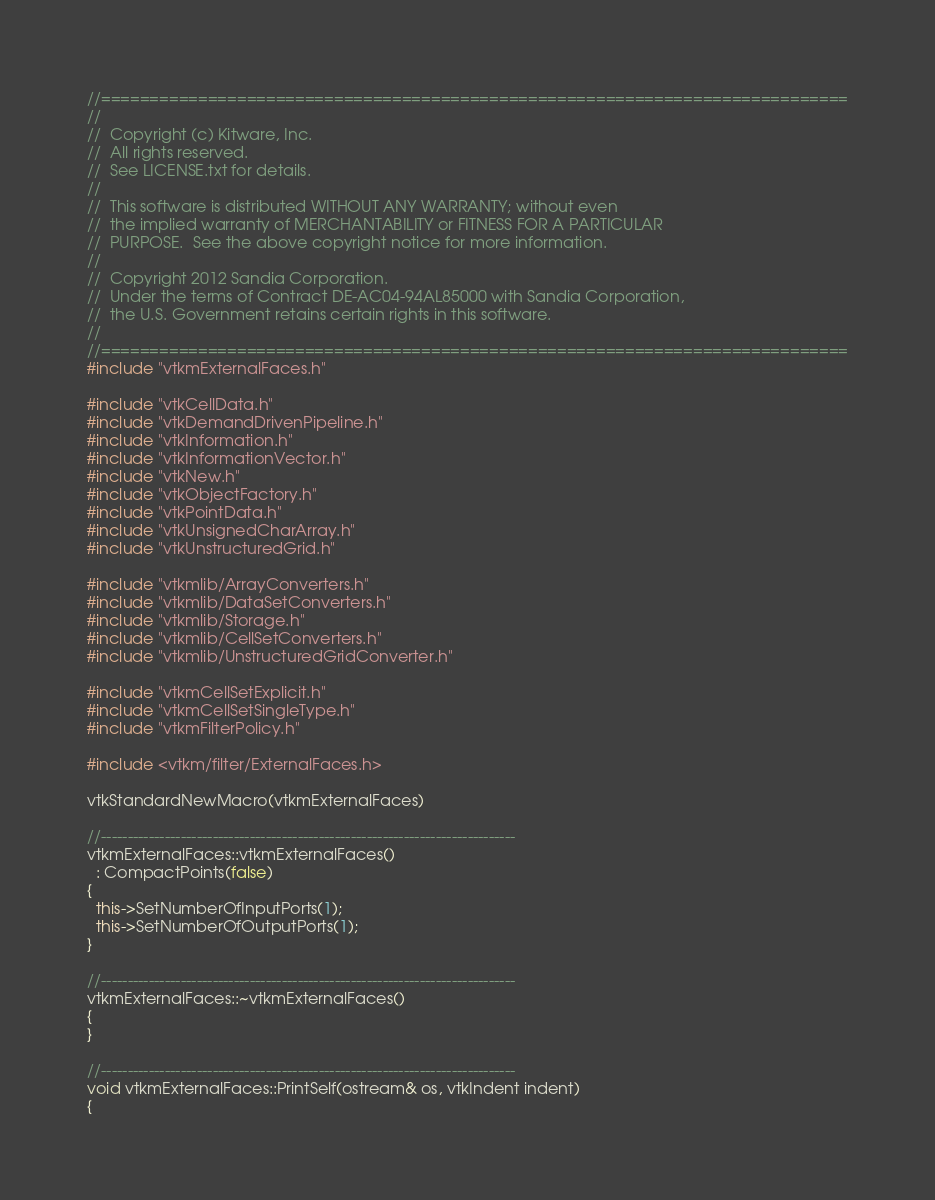<code> <loc_0><loc_0><loc_500><loc_500><_C++_>//=============================================================================
//
//  Copyright (c) Kitware, Inc.
//  All rights reserved.
//  See LICENSE.txt for details.
//
//  This software is distributed WITHOUT ANY WARRANTY; without even
//  the implied warranty of MERCHANTABILITY or FITNESS FOR A PARTICULAR
//  PURPOSE.  See the above copyright notice for more information.
//
//  Copyright 2012 Sandia Corporation.
//  Under the terms of Contract DE-AC04-94AL85000 with Sandia Corporation,
//  the U.S. Government retains certain rights in this software.
//
//=============================================================================
#include "vtkmExternalFaces.h"

#include "vtkCellData.h"
#include "vtkDemandDrivenPipeline.h"
#include "vtkInformation.h"
#include "vtkInformationVector.h"
#include "vtkNew.h"
#include "vtkObjectFactory.h"
#include "vtkPointData.h"
#include "vtkUnsignedCharArray.h"
#include "vtkUnstructuredGrid.h"

#include "vtkmlib/ArrayConverters.h"
#include "vtkmlib/DataSetConverters.h"
#include "vtkmlib/Storage.h"
#include "vtkmlib/CellSetConverters.h"
#include "vtkmlib/UnstructuredGridConverter.h"

#include "vtkmCellSetExplicit.h"
#include "vtkmCellSetSingleType.h"
#include "vtkmFilterPolicy.h"

#include <vtkm/filter/ExternalFaces.h>

vtkStandardNewMacro(vtkmExternalFaces)

//------------------------------------------------------------------------------
vtkmExternalFaces::vtkmExternalFaces()
  : CompactPoints(false)
{
  this->SetNumberOfInputPorts(1);
  this->SetNumberOfOutputPorts(1);
}

//------------------------------------------------------------------------------
vtkmExternalFaces::~vtkmExternalFaces()
{
}

//------------------------------------------------------------------------------
void vtkmExternalFaces::PrintSelf(ostream& os, vtkIndent indent)
{</code> 